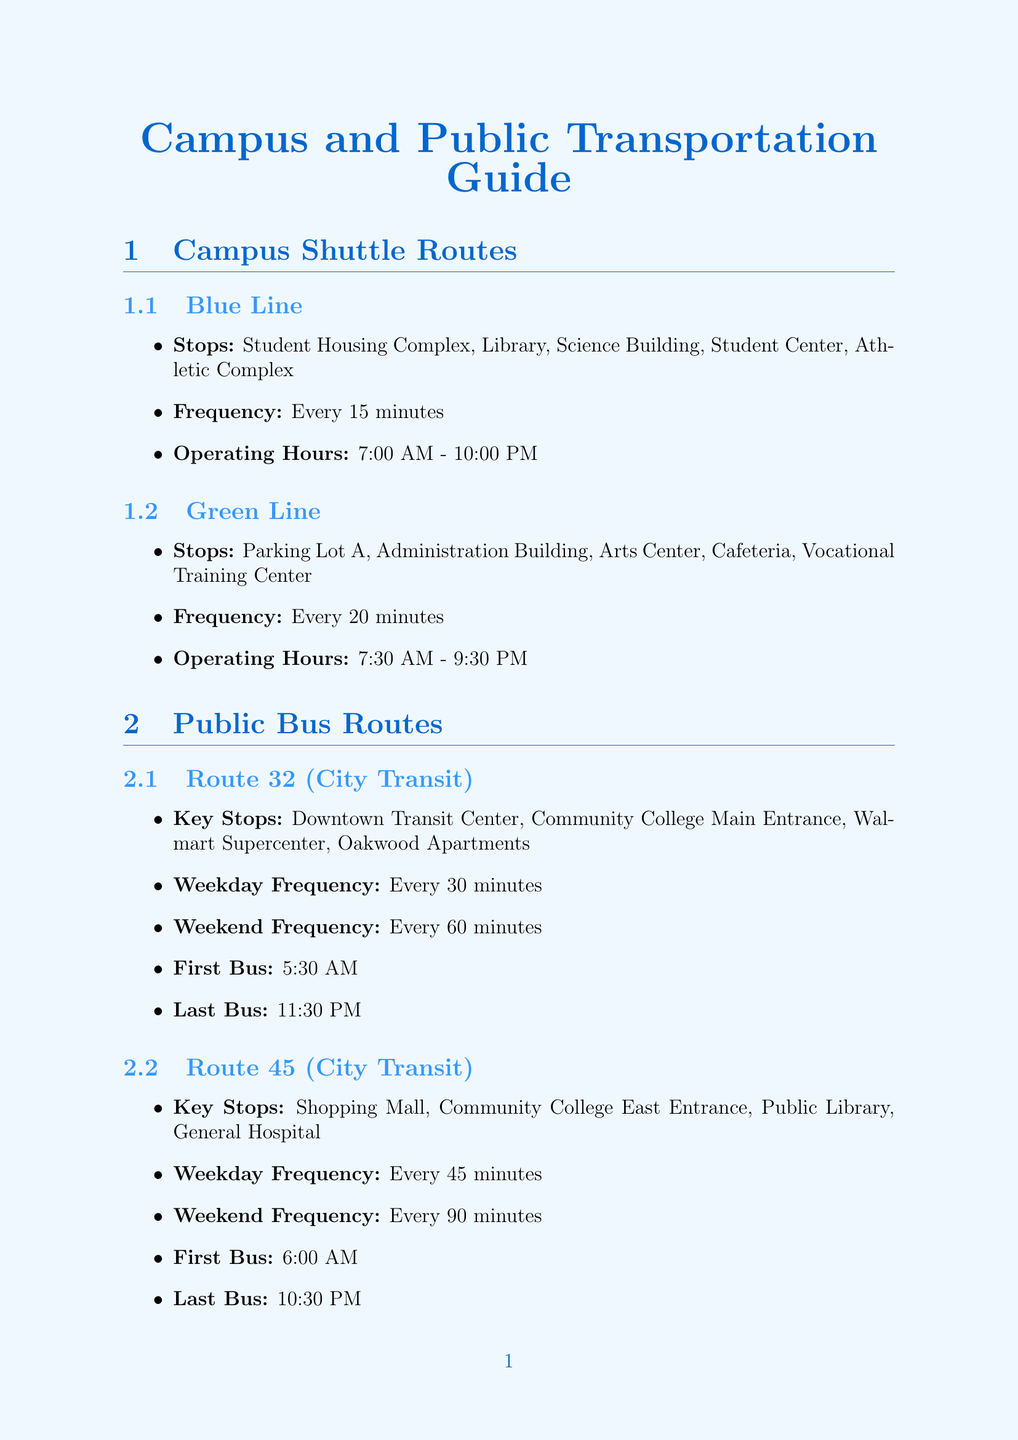What is the frequency of the Blue Line shuttle? The frequency is stated as every 15 minutes in the document.
Answer: Every 15 minutes What are the operating hours for the Green Line? The document specifies the operating hours from 7:30 AM to 9:30 PM for the Green Line.
Answer: 7:30 AM - 9:30 PM How many stops does the Route 32 bus have? The document lists four key stops along the Route 32 bus route.
Answer: 4 What is the estimated cost of a ride with Lyft to campus? The estimated cost mentioned in the document ranges between $7 and $11 for a Lyft ride to campus.
Answer: $7-11 What is the distance from Main Entrance to Target? The document states that Target is located 2 miles from the Main Entrance.
Answer: 2 miles How much does the Student Semester Pass cost? The document indicates that the cost of the Student Semester Pass is $80 per semester.
Answer: $80 per semester What is the average wait time for an Uber ride? The average wait time for an Uber ride, as per the document, is 5 to 10 minutes.
Answer: 5-10 minutes Which job location is on campus? The document specifies the Campus Bookstore as the job location on campus.
Answer: Campus Bookstore What is the bike rental rate for students? The document mentions that the bike rental rate for students is $0.50 per 30 minutes.
Answer: $0.50 per 30 minutes 